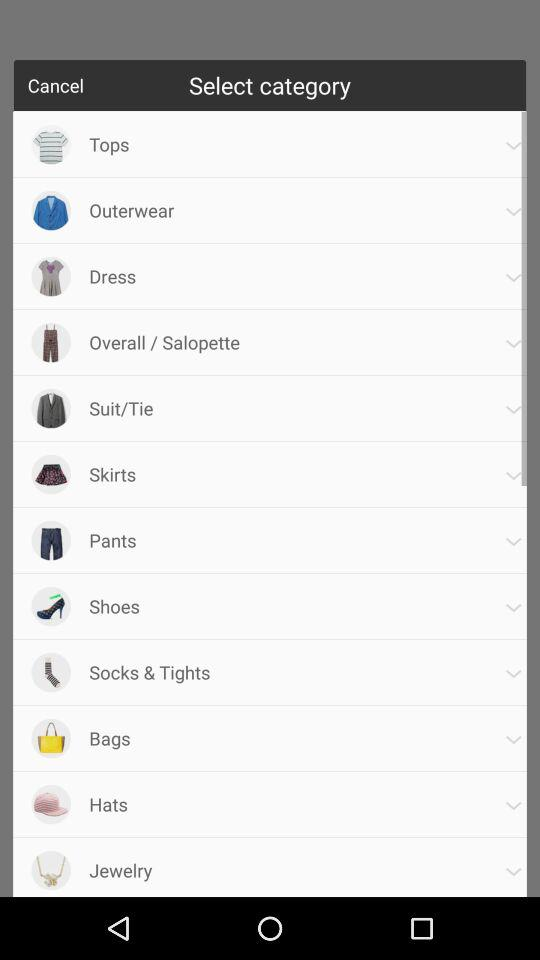What are the different categories available? The different available categories are "Tops", "Outerwear", "Dress", "Overall / Salopette", "Suit/Tie", "Skirts", "Pants", "Shoes", "Socks & Tights", "Bags", "Hats" and "Jewelry". 